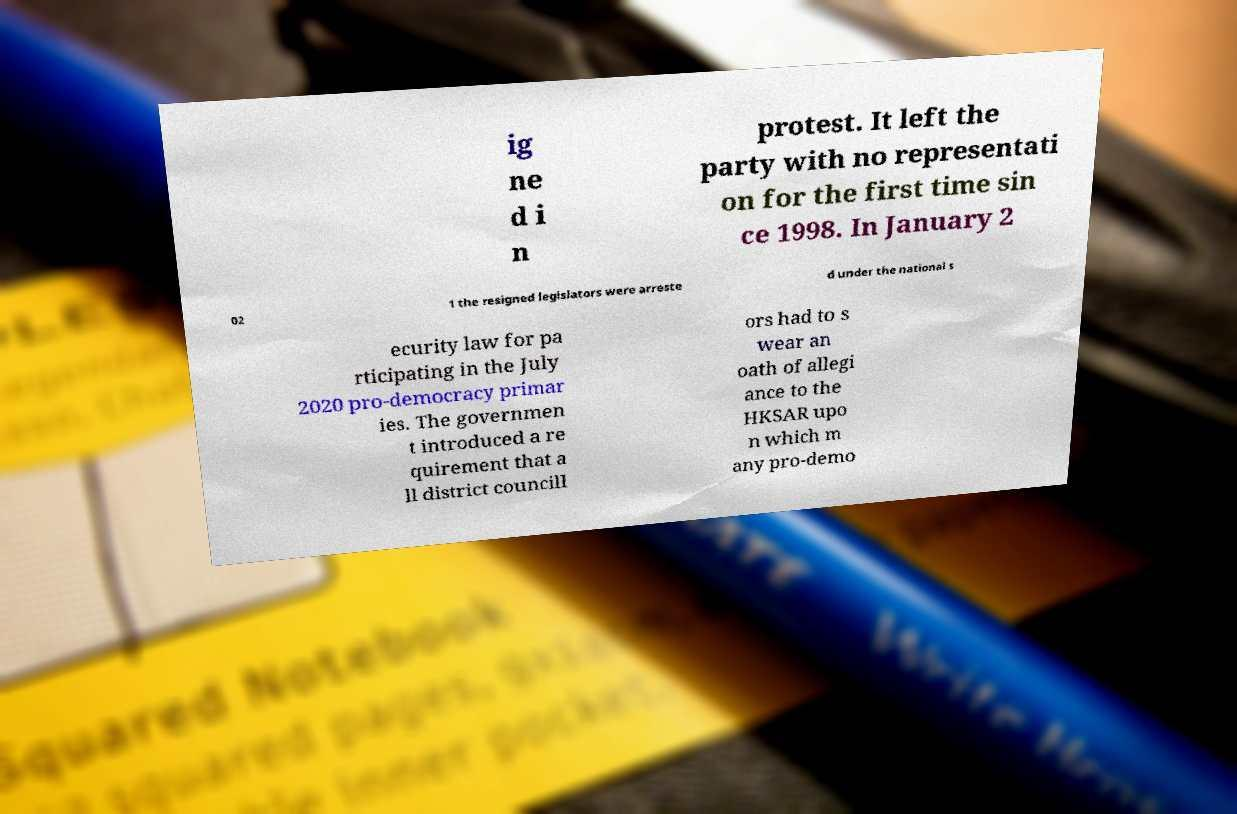Could you assist in decoding the text presented in this image and type it out clearly? ig ne d i n protest. It left the party with no representati on for the first time sin ce 1998. In January 2 02 1 the resigned legislators were arreste d under the national s ecurity law for pa rticipating in the July 2020 pro-democracy primar ies. The governmen t introduced a re quirement that a ll district councill ors had to s wear an oath of allegi ance to the HKSAR upo n which m any pro-demo 